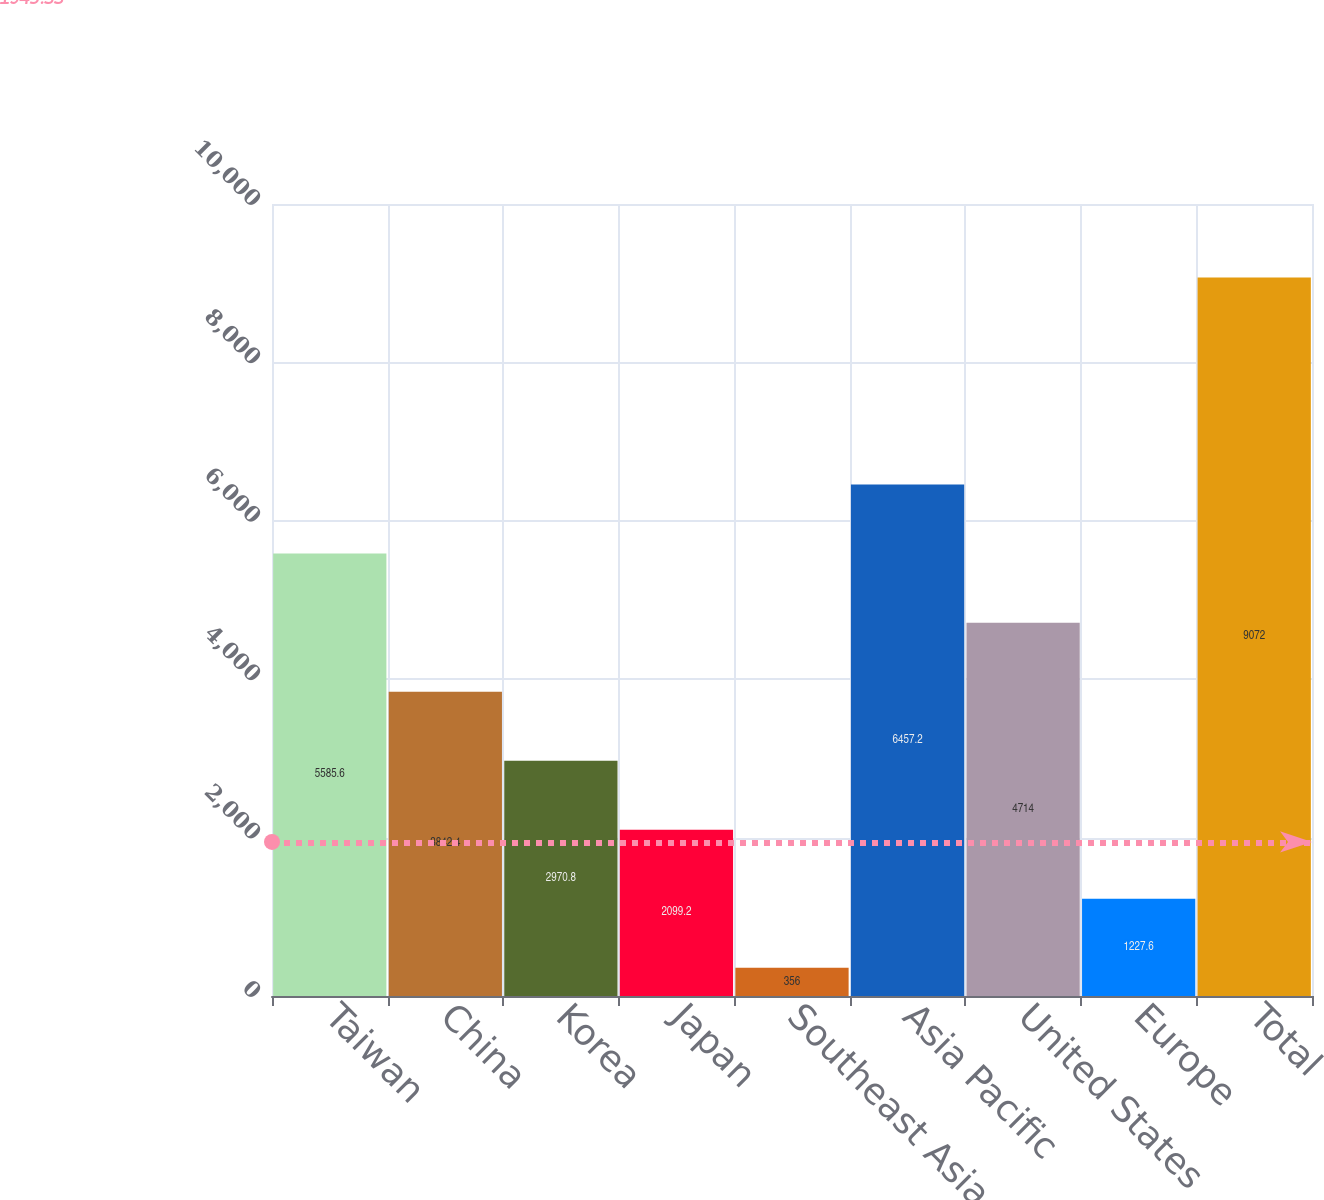Convert chart. <chart><loc_0><loc_0><loc_500><loc_500><bar_chart><fcel>Taiwan<fcel>China<fcel>Korea<fcel>Japan<fcel>Southeast Asia<fcel>Asia Pacific<fcel>United States<fcel>Europe<fcel>Total<nl><fcel>5585.6<fcel>3842.4<fcel>2970.8<fcel>2099.2<fcel>356<fcel>6457.2<fcel>4714<fcel>1227.6<fcel>9072<nl></chart> 